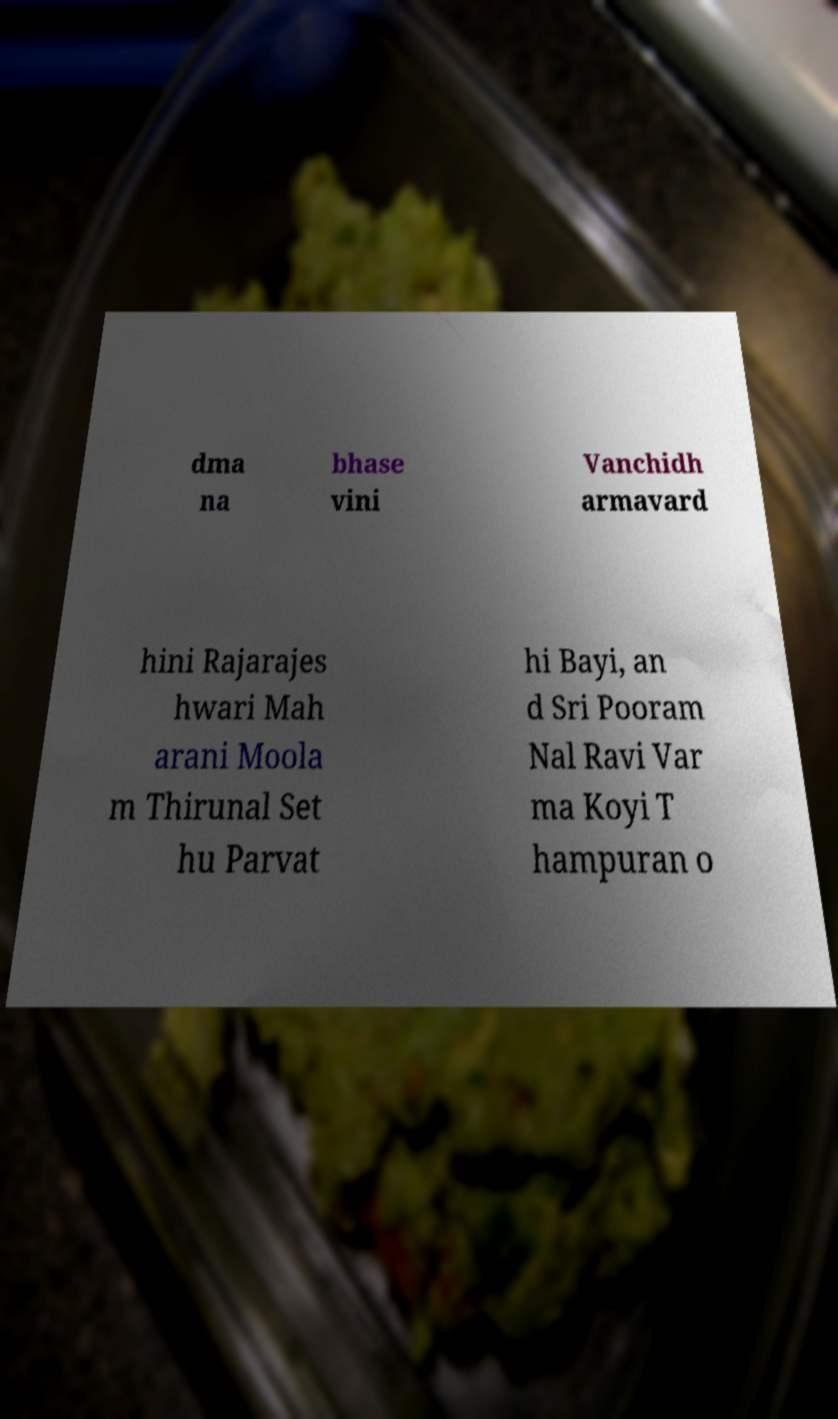There's text embedded in this image that I need extracted. Can you transcribe it verbatim? dma na bhase vini Vanchidh armavard hini Rajarajes hwari Mah arani Moola m Thirunal Set hu Parvat hi Bayi, an d Sri Pooram Nal Ravi Var ma Koyi T hampuran o 